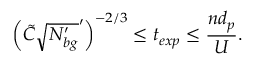<formula> <loc_0><loc_0><loc_500><loc_500>\left ( \tilde { C } \sqrt { N _ { b g } ^ { \prime } } ^ { \prime } \right ) ^ { - 2 / 3 } \leq t _ { e x p } \leq \frac { n d _ { p } } { U } .</formula> 